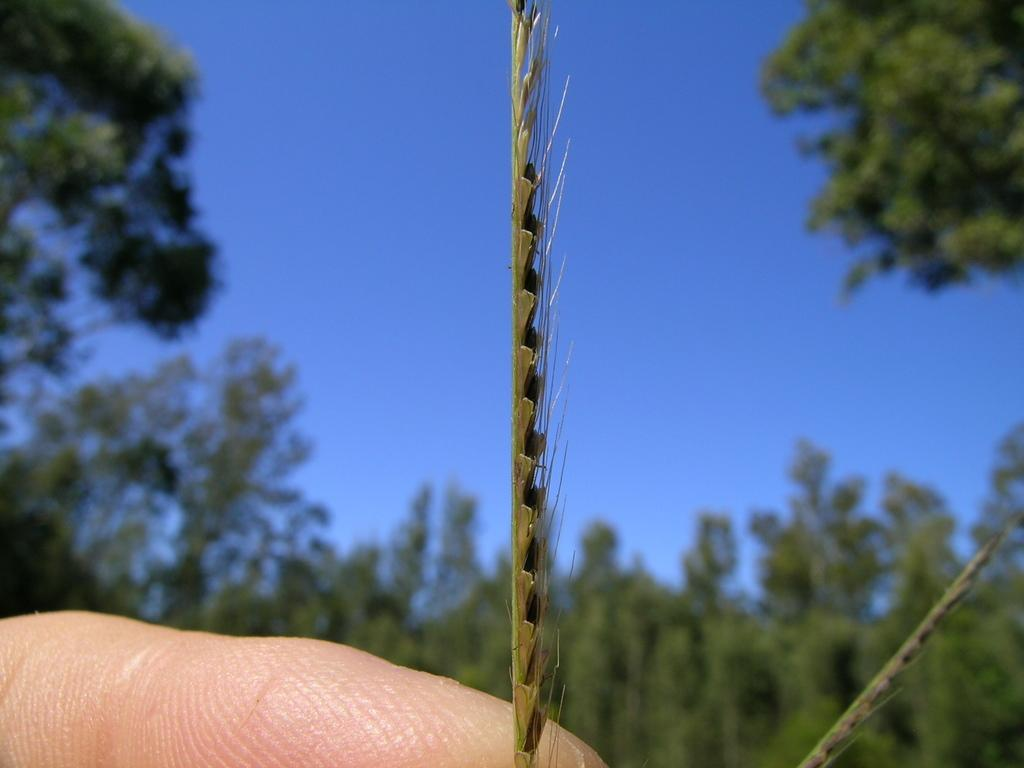What is the main subject of the image? There is a finger in the image. What type of natural environment is depicted in the image? There is grass in the image, and trees are visible in the background. What can be seen in the sky in the image? The sky is blue and visible in the background of the image. How would you describe the quality of the image? The image is blurred. What type of soda is being poured from the finger in the image? There is no soda present in the image; it only features a finger and a natural environment. Can you see a cork in the image? There is no cork present in the image. 